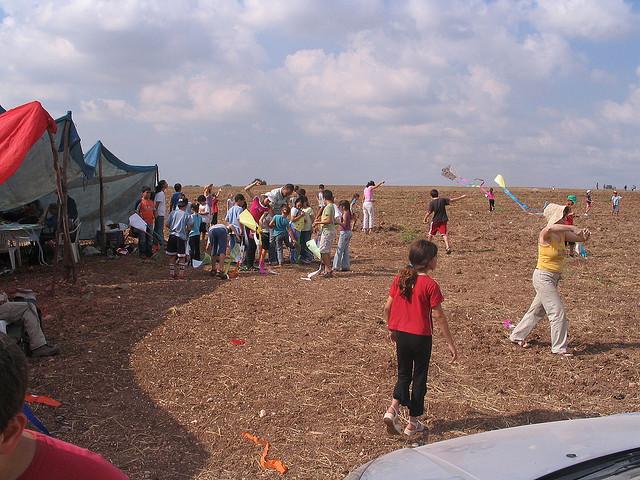What are these people doing?
Quick response, please. Flying kites. What color is the tent in the back?
Quick response, please. Blue. What are the white forms in the sky?
Give a very brief answer. Clouds. 